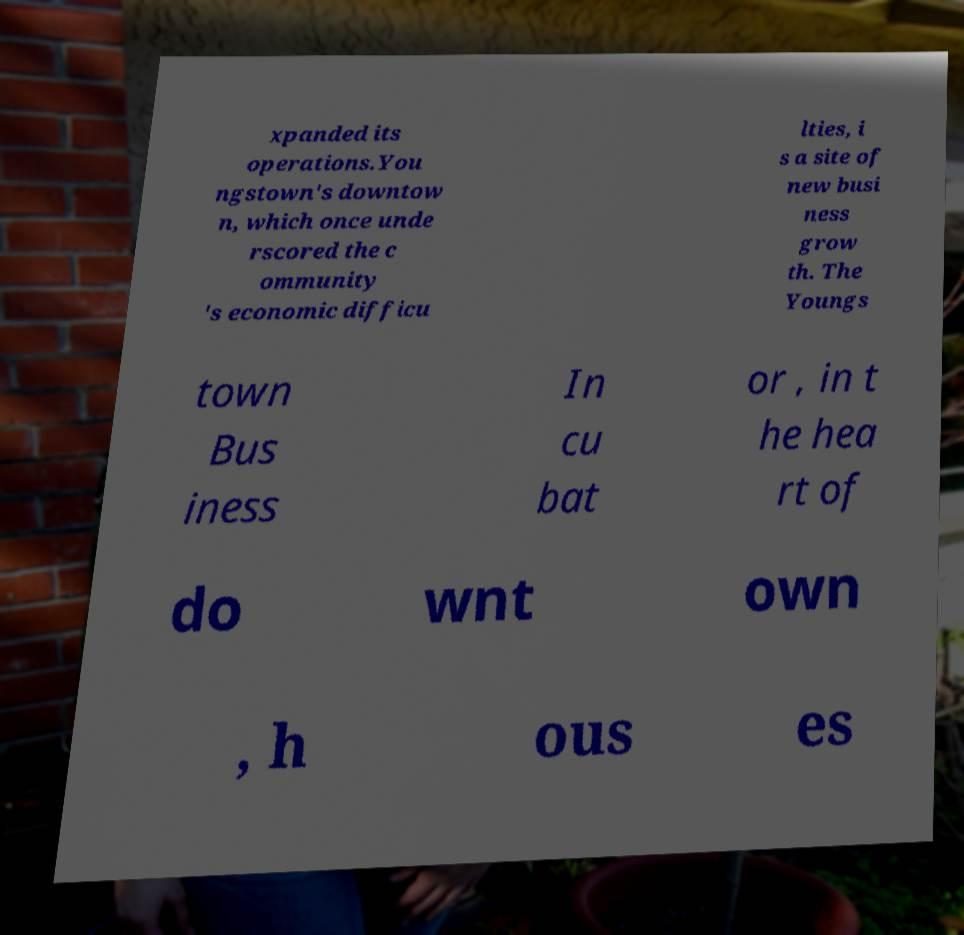Please read and relay the text visible in this image. What does it say? xpanded its operations.You ngstown's downtow n, which once unde rscored the c ommunity 's economic difficu lties, i s a site of new busi ness grow th. The Youngs town Bus iness In cu bat or , in t he hea rt of do wnt own , h ous es 